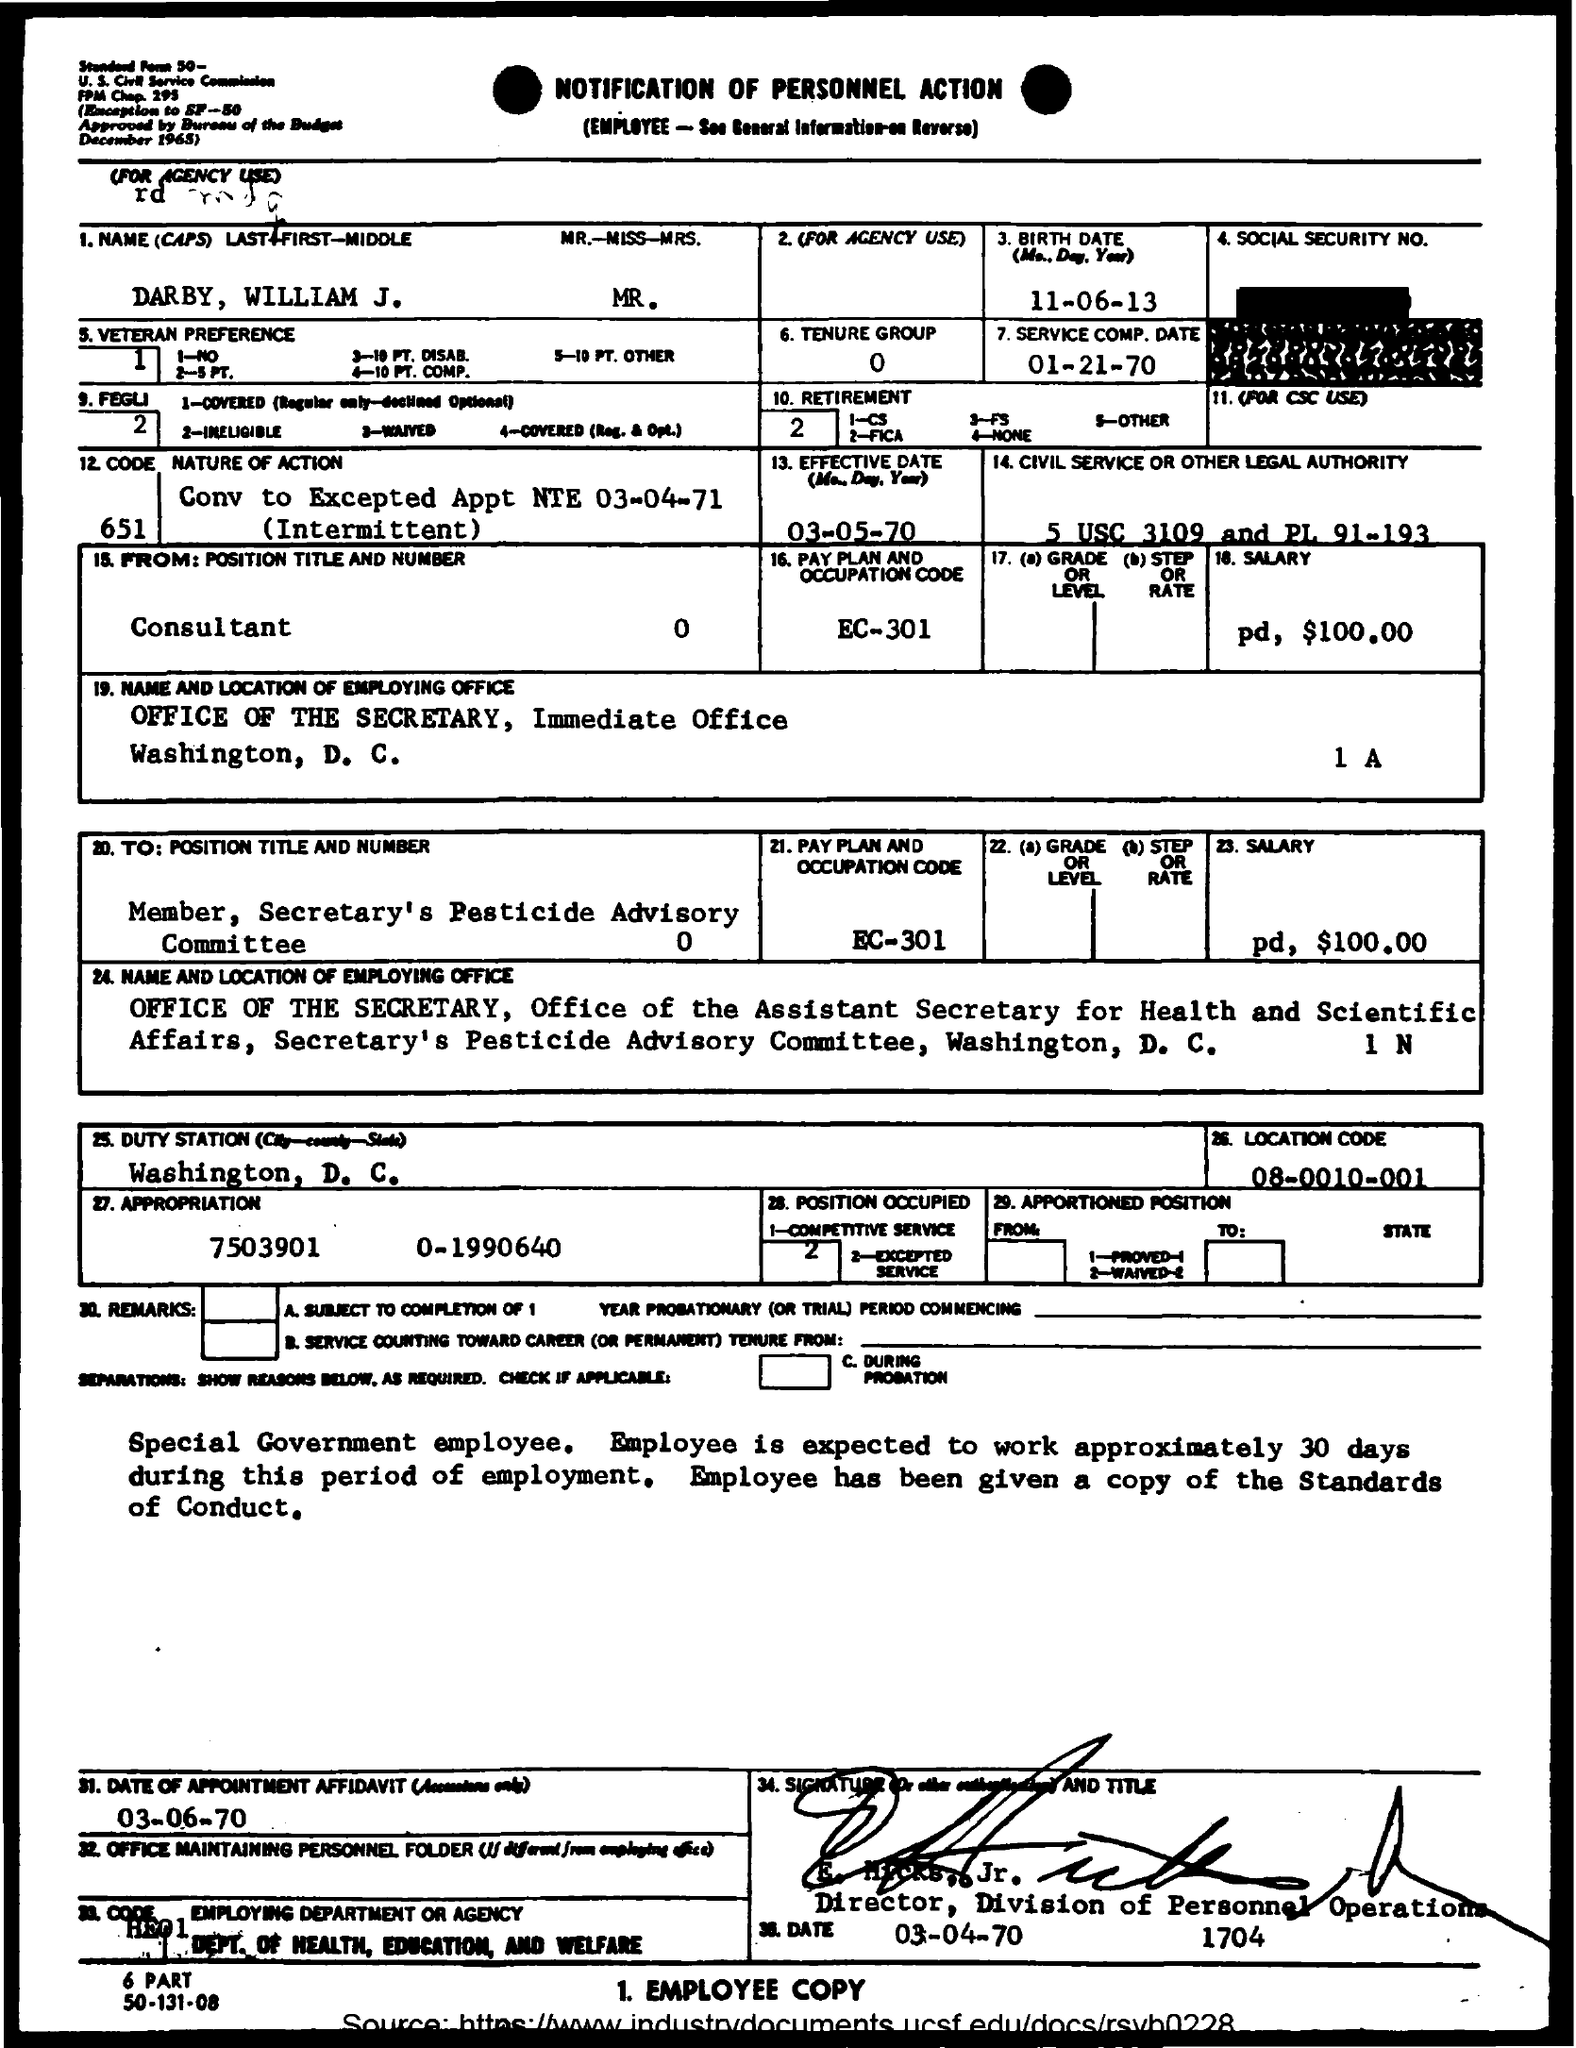What is the birth date mentioned ?
Give a very brief answer. 11-06-13. What is the service comp . date
Ensure brevity in your answer.  01-21-70. How much is the salary
Provide a succinct answer. Pd, $100.00. In which city office is located ?
Your answer should be very brief. WASHINGTON, D.C. What is the effective date (mon, day , year )
Give a very brief answer. 03-05-70. What is the pay plan and occupation code
Offer a terse response. EC-301. What is the appropriation ?
Provide a succinct answer. 7503901      0-1990640. What is the location code ?
Provide a succinct answer. 08-0010-001. 